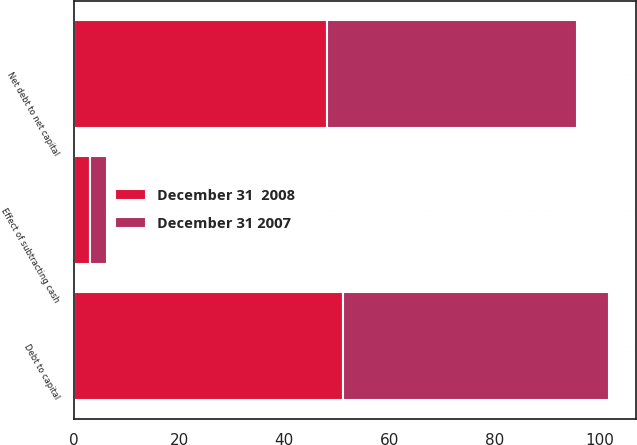Convert chart to OTSL. <chart><loc_0><loc_0><loc_500><loc_500><stacked_bar_chart><ecel><fcel>Net debt to net capital<fcel>Effect of subtracting cash<fcel>Debt to capital<nl><fcel>December 31  2008<fcel>48.2<fcel>3<fcel>51.2<nl><fcel>December 31 2007<fcel>47.4<fcel>3.2<fcel>50.6<nl></chart> 